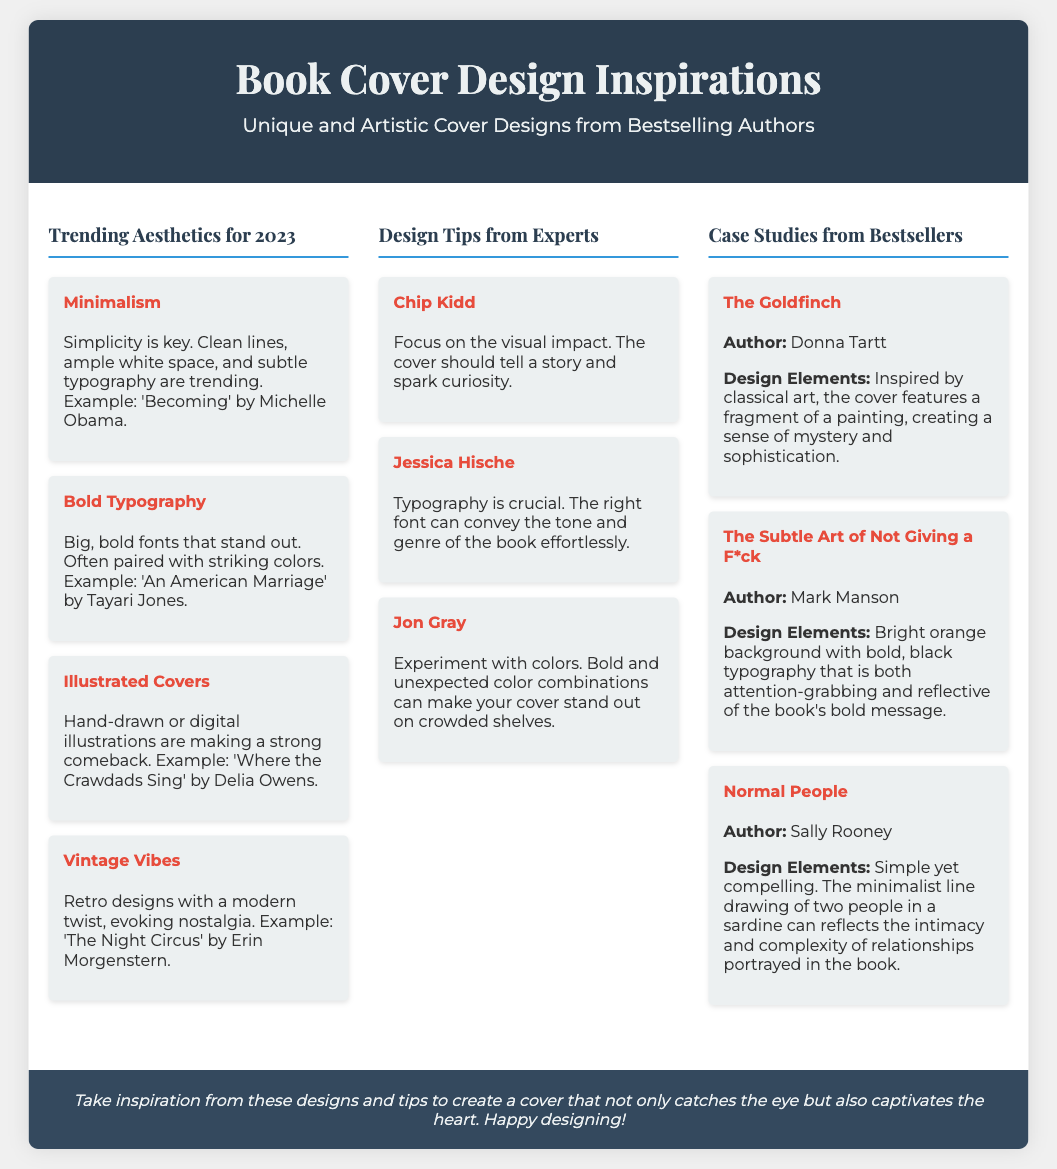What is the title of the flyer? The title of the flyer is prominently displayed at the top of the document.
Answer: Book Cover Design Inspirations Who is the author of "The Goldfinch"? The author of "The Goldfinch" is mentioned in the case study section.
Answer: Donna Tartt What design aesthetic features clean lines and ample white space? This aesthetic is discussed in the trending aesthetics section of the flyer.
Answer: Minimalism Which design tip emphasizes the importance of typography? This information can be found in the design tips section and relates to a specific expert.
Answer: Jessica Hische Which book has a bright orange background and bold typography? This detail is highlighted in the case study section under the specific book title.
Answer: The Subtle Art of Not Giving a F*ck What is a common design strategy mentioned for book covers? This can be inferred from multiple design tips and trends shared in the flyer.
Answer: Experiment with colors How many trending aesthetics are listed for 2023? This number can be counted from the trending aesthetics section of the document.
Answer: Four What aesthetic evokes nostalgia according to the flyer? This aesthetic is categorized under the trending aesthetics in the document.
Answer: Vintage Vibes 